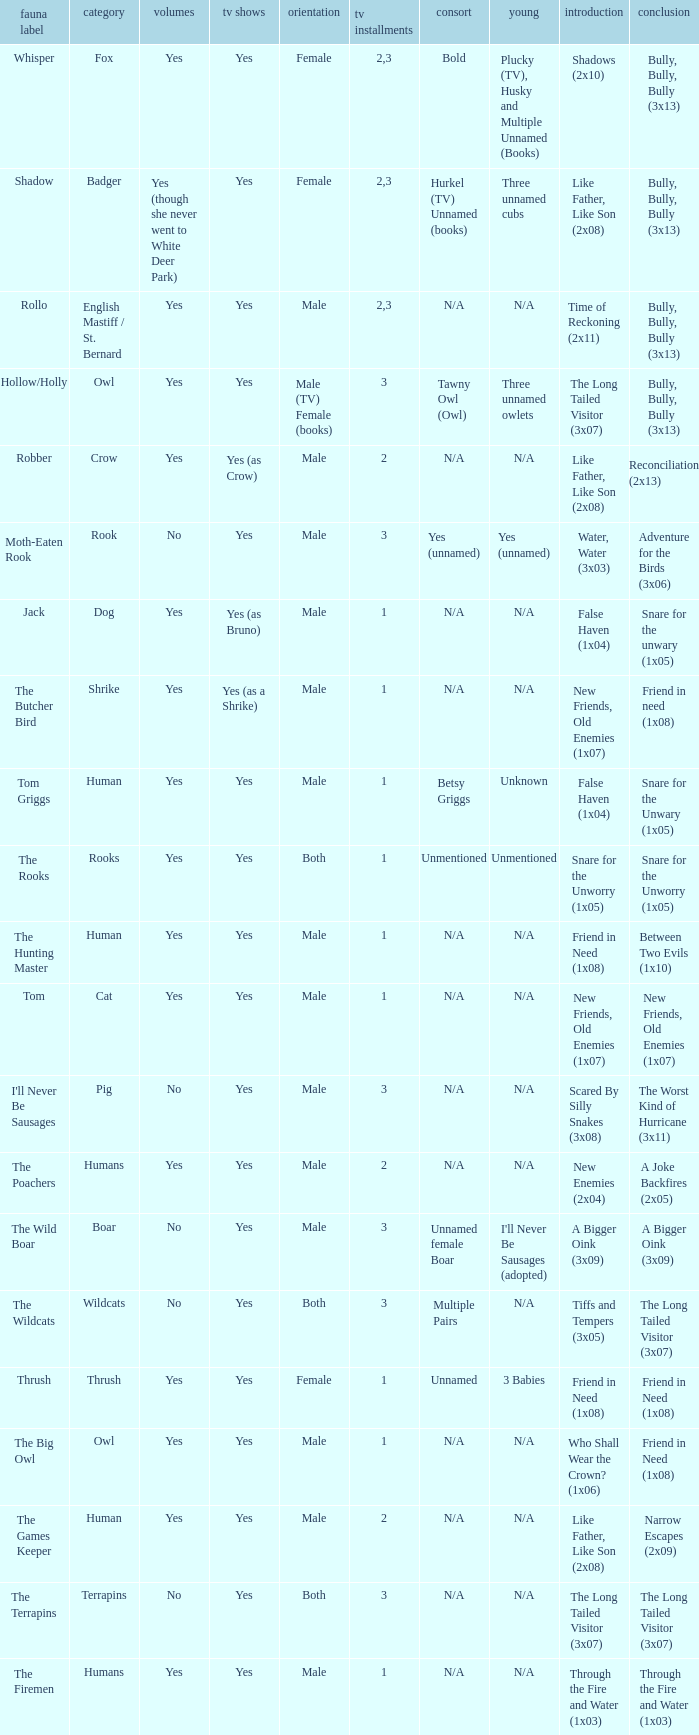What show has a boar? Yes. 